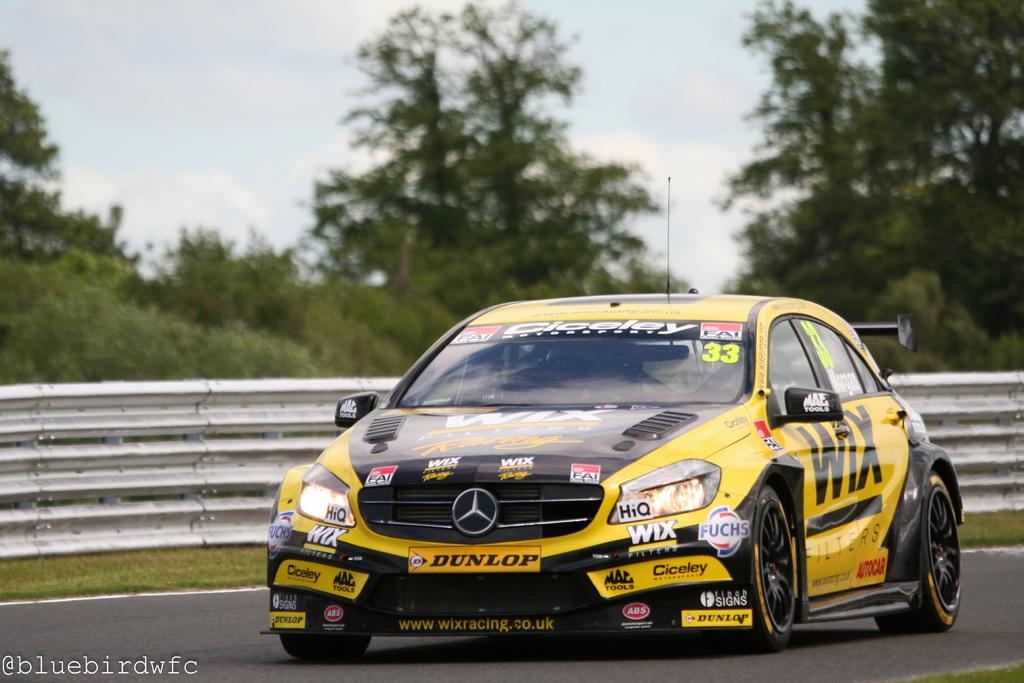Provide a one-sentence caption for the provided image. The yellow car has a WIX banner on the front fender. 